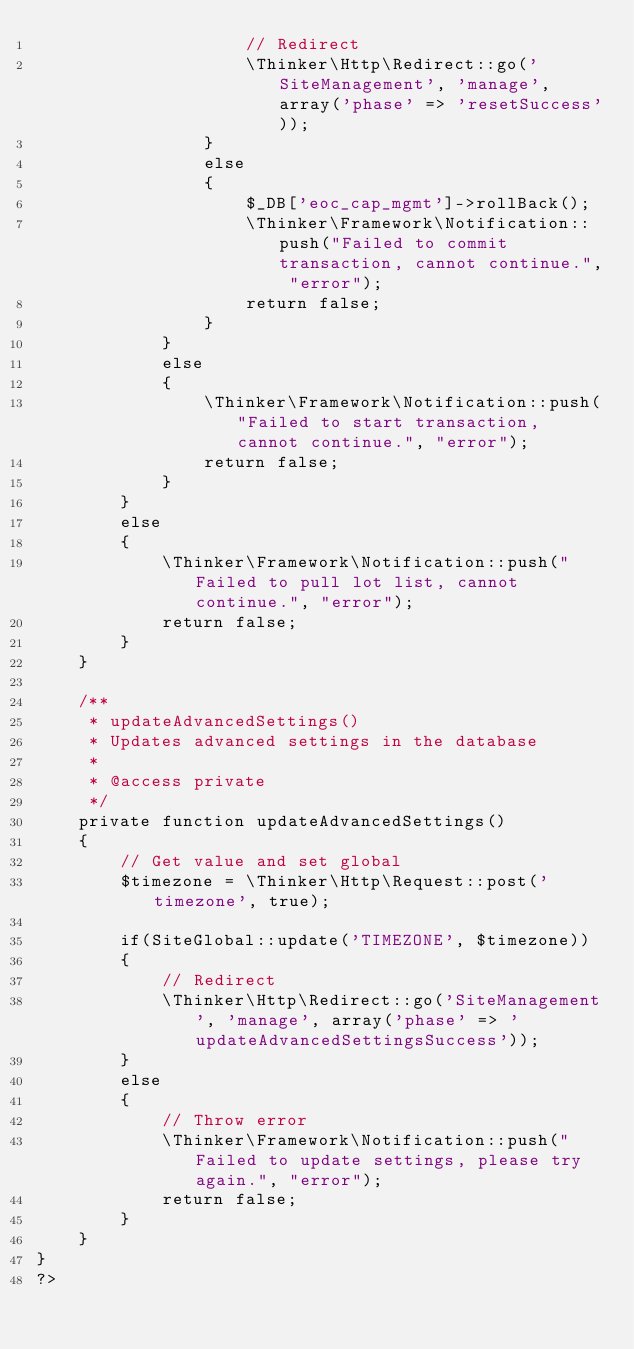<code> <loc_0><loc_0><loc_500><loc_500><_PHP_>					// Redirect
					\Thinker\Http\Redirect::go('SiteManagement', 'manage', array('phase' => 'resetSuccess'));
				}
				else
				{
					$_DB['eoc_cap_mgmt']->rollBack();
					\Thinker\Framework\Notification::push("Failed to commit transaction, cannot continue.", "error");
					return false;
				}
			}
			else
			{
				\Thinker\Framework\Notification::push("Failed to start transaction, cannot continue.", "error");
				return false;
			}
		}
		else
		{
			\Thinker\Framework\Notification::push("Failed to pull lot list, cannot continue.", "error");
			return false;
		}
	}

	/**
	 * updateAdvancedSettings()
	 * Updates advanced settings in the database
	 *
	 * @access private
	 */
	private function updateAdvancedSettings()
	{
		// Get value and set global
		$timezone = \Thinker\Http\Request::post('timezone', true);

		if(SiteGlobal::update('TIMEZONE', $timezone))
		{
			// Redirect
			\Thinker\Http\Redirect::go('SiteManagement', 'manage', array('phase' => 'updateAdvancedSettingsSuccess'));
		}
		else
		{
			// Throw error
			\Thinker\Framework\Notification::push("Failed to update settings, please try again.", "error");
			return false;
		}
	}
}
?></code> 